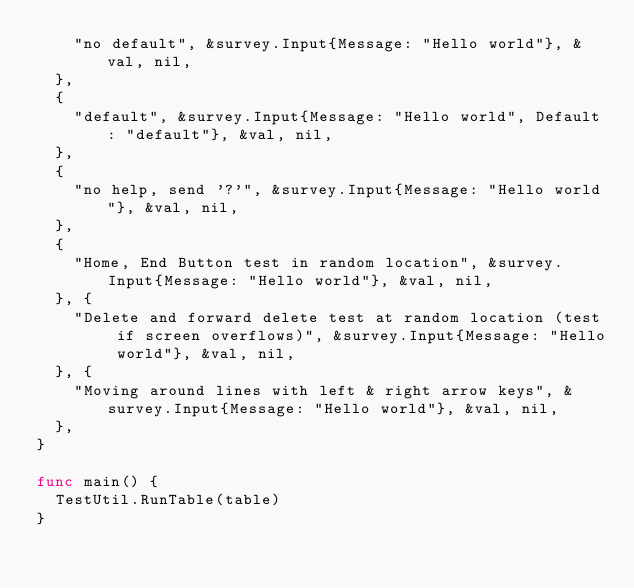<code> <loc_0><loc_0><loc_500><loc_500><_Go_>		"no default", &survey.Input{Message: "Hello world"}, &val, nil,
	},
	{
		"default", &survey.Input{Message: "Hello world", Default: "default"}, &val, nil,
	},
	{
		"no help, send '?'", &survey.Input{Message: "Hello world"}, &val, nil,
	},
	{
		"Home, End Button test in random location", &survey.Input{Message: "Hello world"}, &val, nil,
	}, {
		"Delete and forward delete test at random location (test if screen overflows)", &survey.Input{Message: "Hello world"}, &val, nil,
	}, {
		"Moving around lines with left & right arrow keys", &survey.Input{Message: "Hello world"}, &val, nil,
	},
}

func main() {
	TestUtil.RunTable(table)
}
</code> 